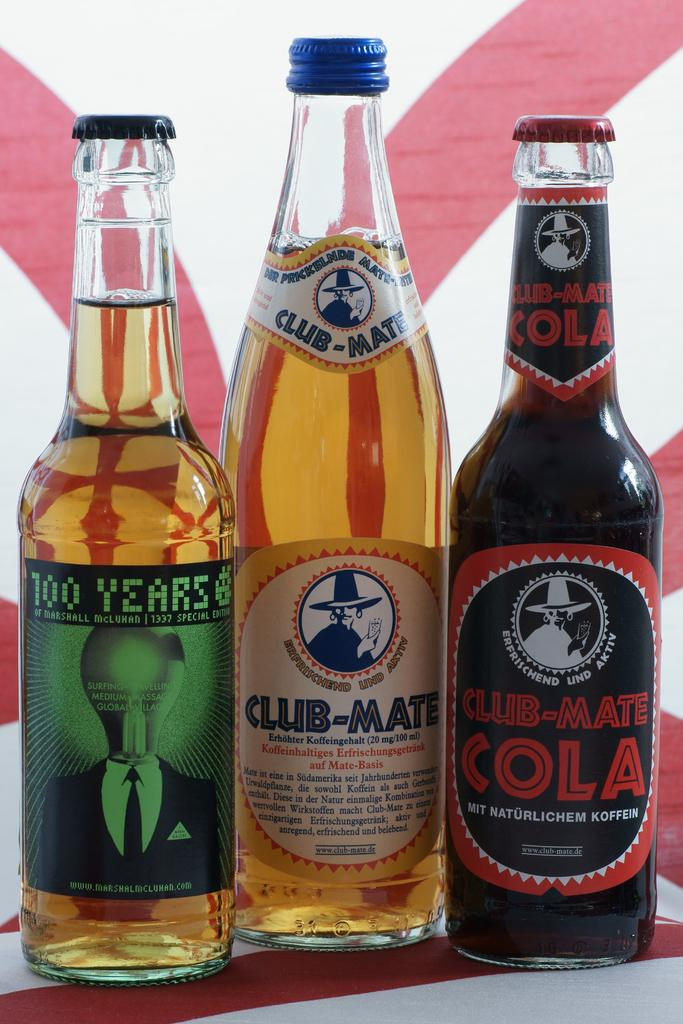<image>
Provide a brief description of the given image. Three different Club-Mate beverages are in a row. 